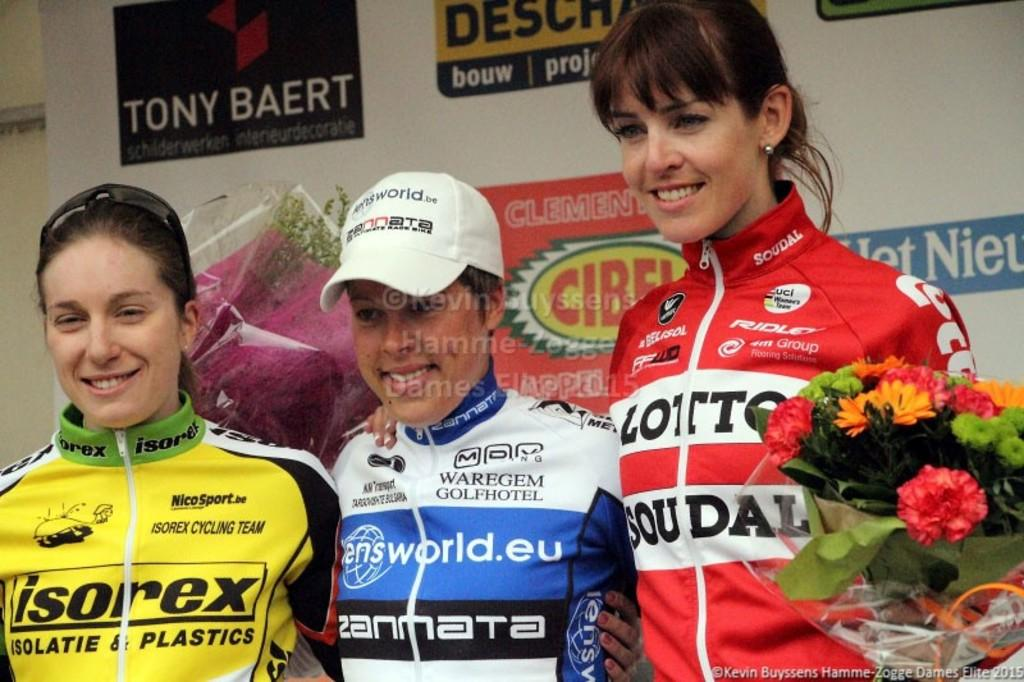How many women are present in the image? There are three women in the image. What is one of the women holding? One of the women is holding a bouquet. What can be seen in the background of the image? There is a banner in the image. Is there another bouquet visible in the image? Yes, there is a bouquet behind the women. What type of collar is visible on the banner in the image? There is no collar present on the banner in the image. How does the banner fold in the image? The banner does not fold in the image; it is unfurled and displayed. 